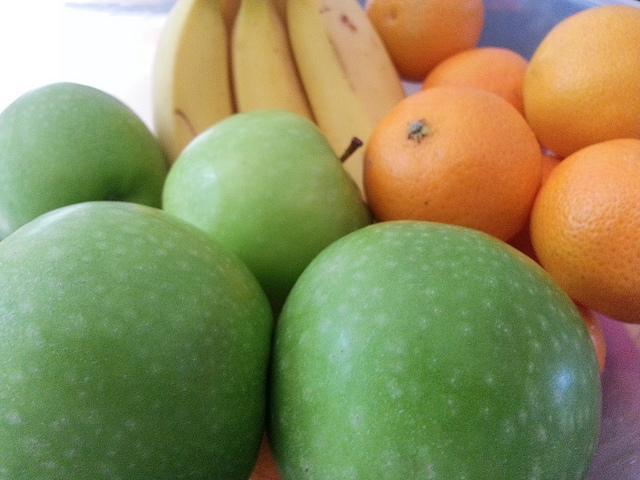What is the green item used in?
Choose the right answer from the provided options to respond to the question.
Options: Cheeseburger, pea soup, apple pie, caesar salad. Apple pie. 